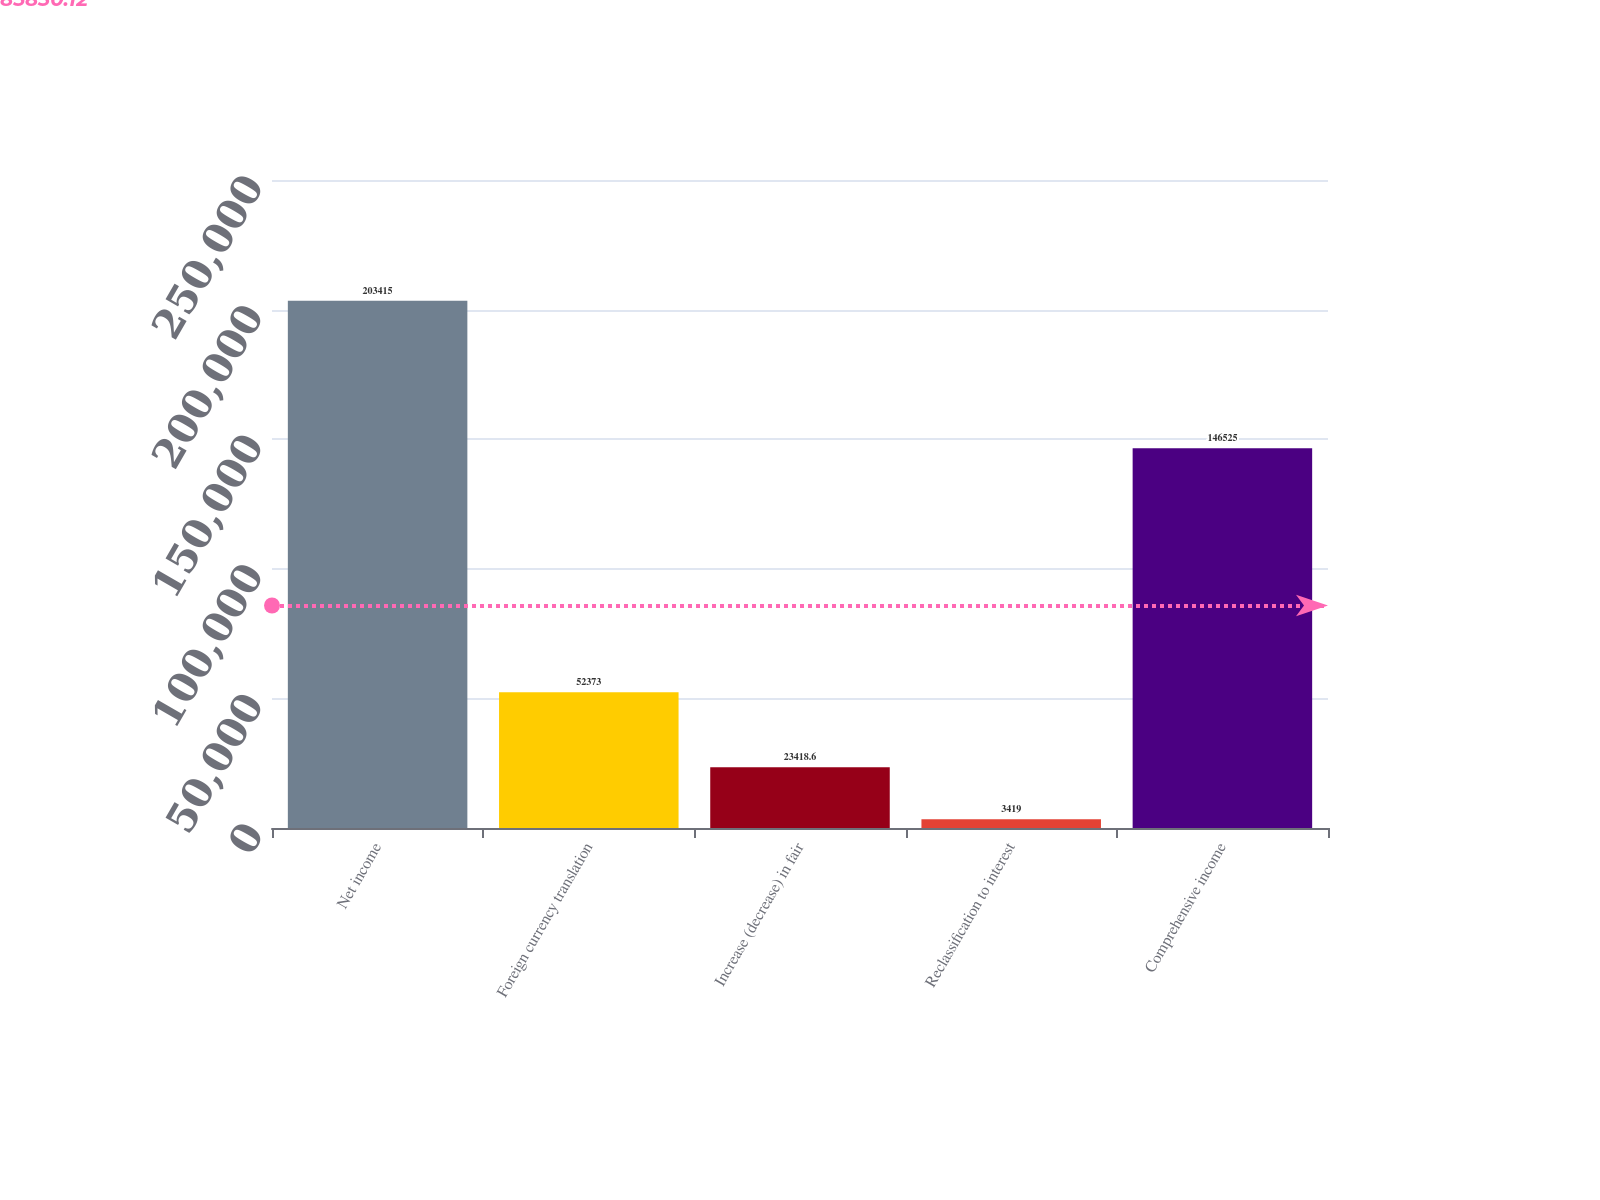<chart> <loc_0><loc_0><loc_500><loc_500><bar_chart><fcel>Net income<fcel>Foreign currency translation<fcel>Increase (decrease) in fair<fcel>Reclassification to interest<fcel>Comprehensive income<nl><fcel>203415<fcel>52373<fcel>23418.6<fcel>3419<fcel>146525<nl></chart> 